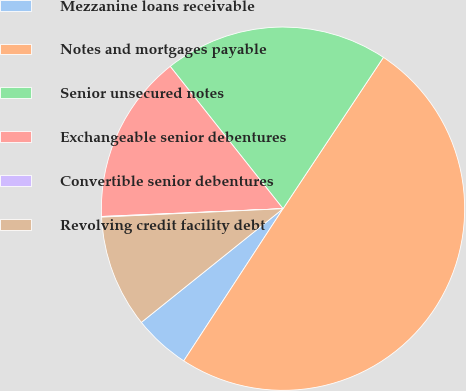Convert chart. <chart><loc_0><loc_0><loc_500><loc_500><pie_chart><fcel>Mezzanine loans receivable<fcel>Notes and mortgages payable<fcel>Senior unsecured notes<fcel>Exchangeable senior debentures<fcel>Convertible senior debentures<fcel>Revolving credit facility debt<nl><fcel>5.04%<fcel>49.88%<fcel>19.99%<fcel>15.01%<fcel>0.06%<fcel>10.02%<nl></chart> 